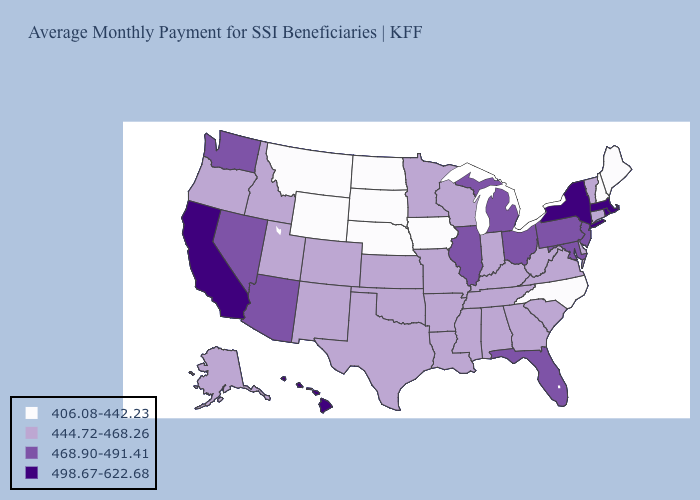Name the states that have a value in the range 498.67-622.68?
Write a very short answer. California, Hawaii, Massachusetts, New York, Rhode Island. What is the highest value in states that border Virginia?
Write a very short answer. 468.90-491.41. Does the map have missing data?
Keep it brief. No. Which states have the lowest value in the South?
Concise answer only. North Carolina. Among the states that border South Carolina , which have the highest value?
Concise answer only. Georgia. Name the states that have a value in the range 444.72-468.26?
Keep it brief. Alabama, Alaska, Arkansas, Colorado, Connecticut, Delaware, Georgia, Idaho, Indiana, Kansas, Kentucky, Louisiana, Minnesota, Mississippi, Missouri, New Mexico, Oklahoma, Oregon, South Carolina, Tennessee, Texas, Utah, Vermont, Virginia, West Virginia, Wisconsin. Which states hav the highest value in the South?
Be succinct. Florida, Maryland. Name the states that have a value in the range 468.90-491.41?
Answer briefly. Arizona, Florida, Illinois, Maryland, Michigan, Nevada, New Jersey, Ohio, Pennsylvania, Washington. Does the map have missing data?
Concise answer only. No. Which states have the lowest value in the West?
Be succinct. Montana, Wyoming. What is the value of Illinois?
Answer briefly. 468.90-491.41. Which states have the lowest value in the USA?
Write a very short answer. Iowa, Maine, Montana, Nebraska, New Hampshire, North Carolina, North Dakota, South Dakota, Wyoming. What is the value of Michigan?
Quick response, please. 468.90-491.41. Name the states that have a value in the range 468.90-491.41?
Short answer required. Arizona, Florida, Illinois, Maryland, Michigan, Nevada, New Jersey, Ohio, Pennsylvania, Washington. 